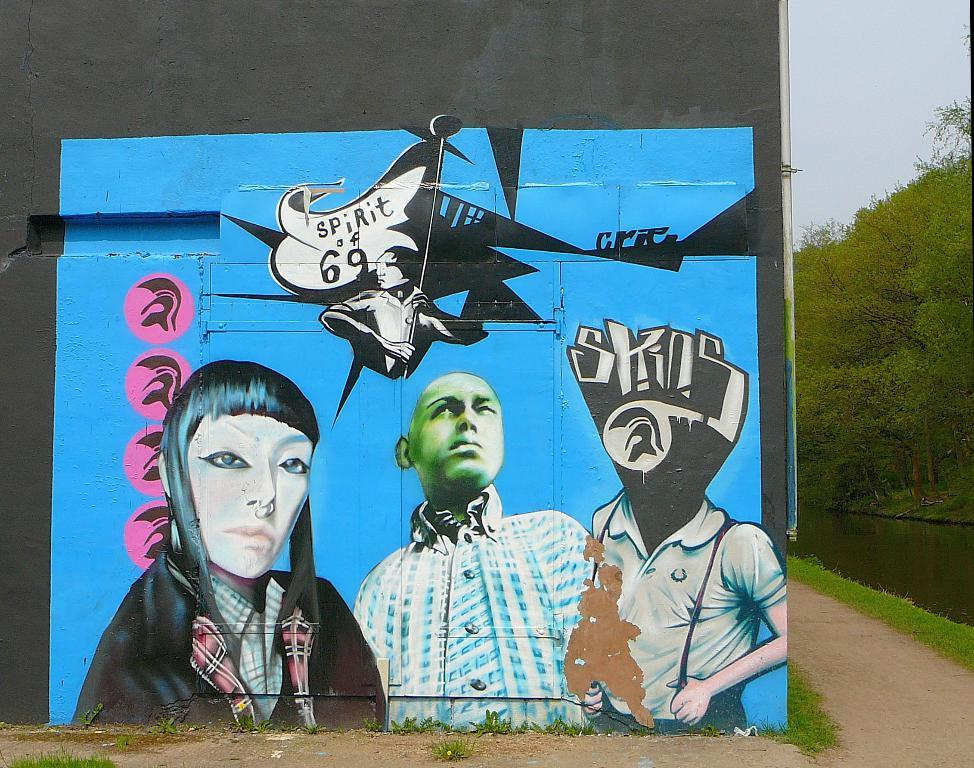What is depicted on the wall in the image? There is a painting on a wall in the image. What type of vegetation is at the bottom of the image? There are plants at the bottom of the image. What can be seen on the right side of the image? There is grass, a walkway, water, trees, and the sky visible on the right side of the image. Where is the sofa located in the image? There is no sofa present in the image. Is there a grape vine growing in the image? There is no grape vine or grapes present in the image. 